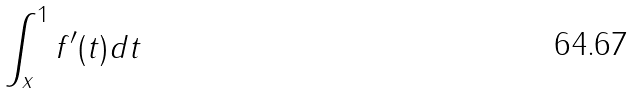Convert formula to latex. <formula><loc_0><loc_0><loc_500><loc_500>\int _ { x } ^ { 1 } f ^ { \prime } ( t ) d t</formula> 